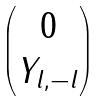<formula> <loc_0><loc_0><loc_500><loc_500>\begin{pmatrix} 0 \\ Y _ { l , - l } \end{pmatrix}</formula> 